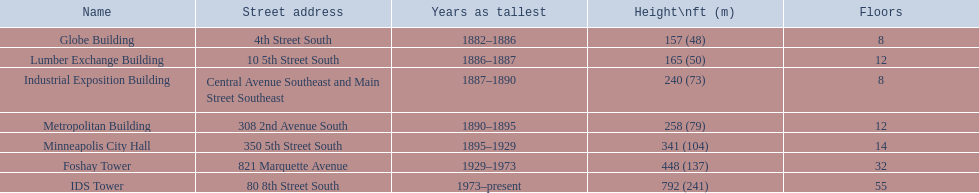In minneapolis, which building comes in second place for height after the ids tower? Foshay Tower. 